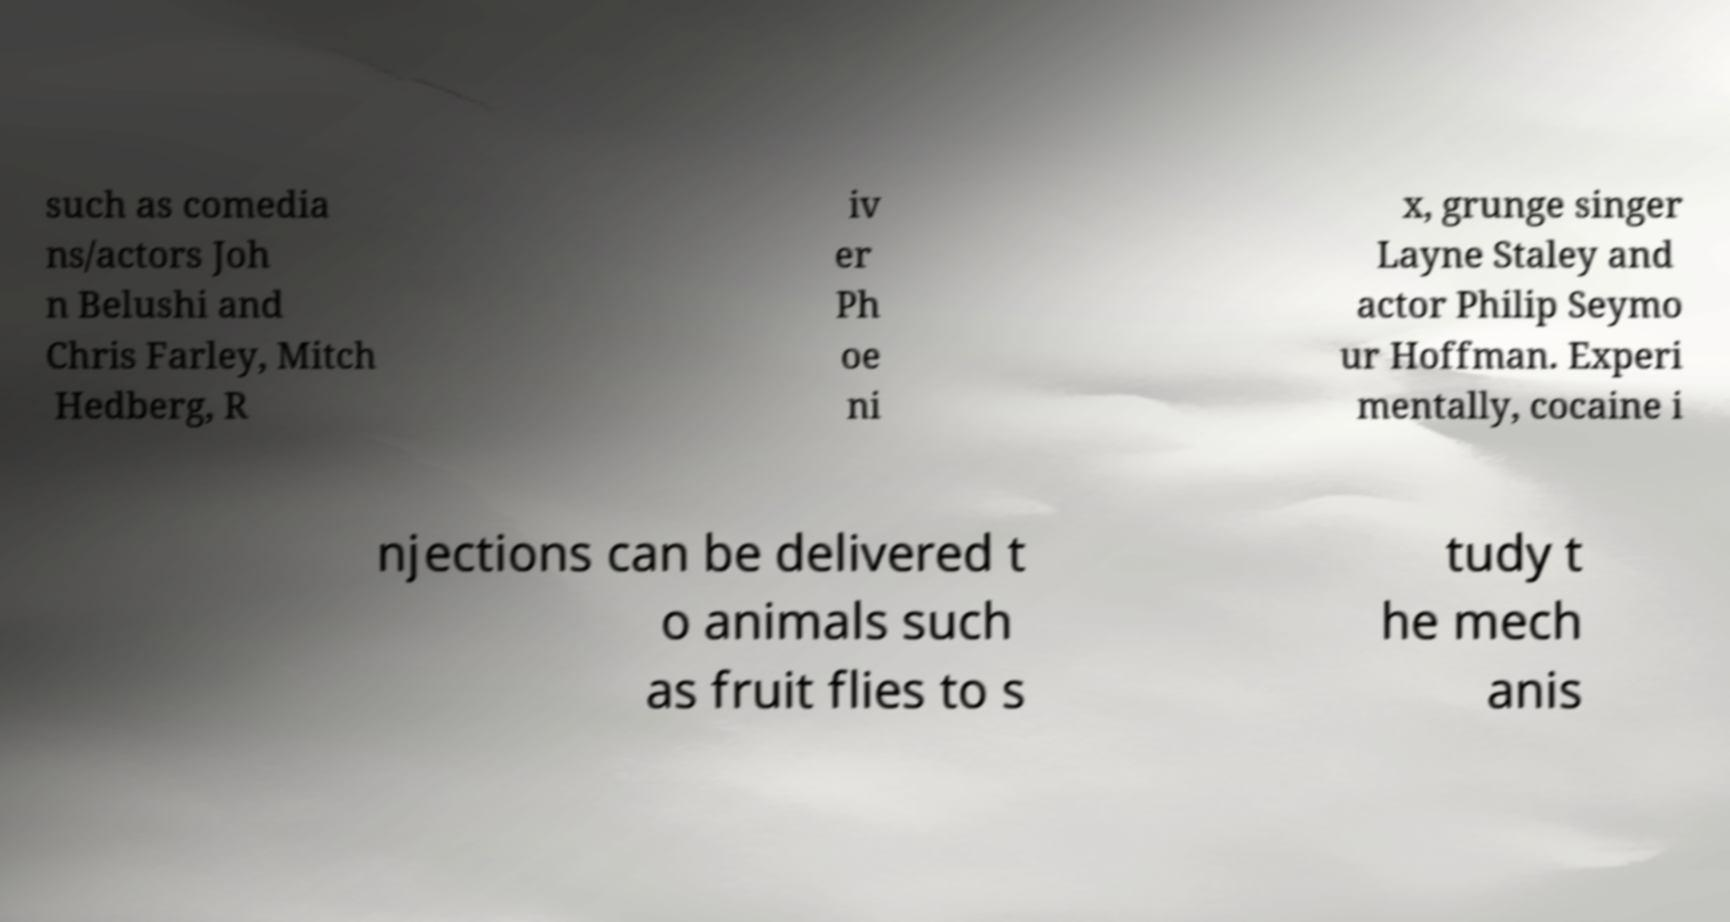Can you accurately transcribe the text from the provided image for me? such as comedia ns/actors Joh n Belushi and Chris Farley, Mitch Hedberg, R iv er Ph oe ni x, grunge singer Layne Staley and actor Philip Seymo ur Hoffman. Experi mentally, cocaine i njections can be delivered t o animals such as fruit flies to s tudy t he mech anis 